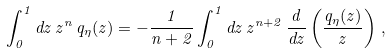<formula> <loc_0><loc_0><loc_500><loc_500>\int _ { 0 } ^ { 1 } d z \, z ^ { n } \, q _ { \eta } ( z ) = - \frac { 1 } { n + 2 } \int _ { 0 } ^ { 1 } d z \, z ^ { n + 2 } \, \frac { d } { d z } \left ( \frac { q _ { \eta } ( z ) } { z } \right ) \, ,</formula> 